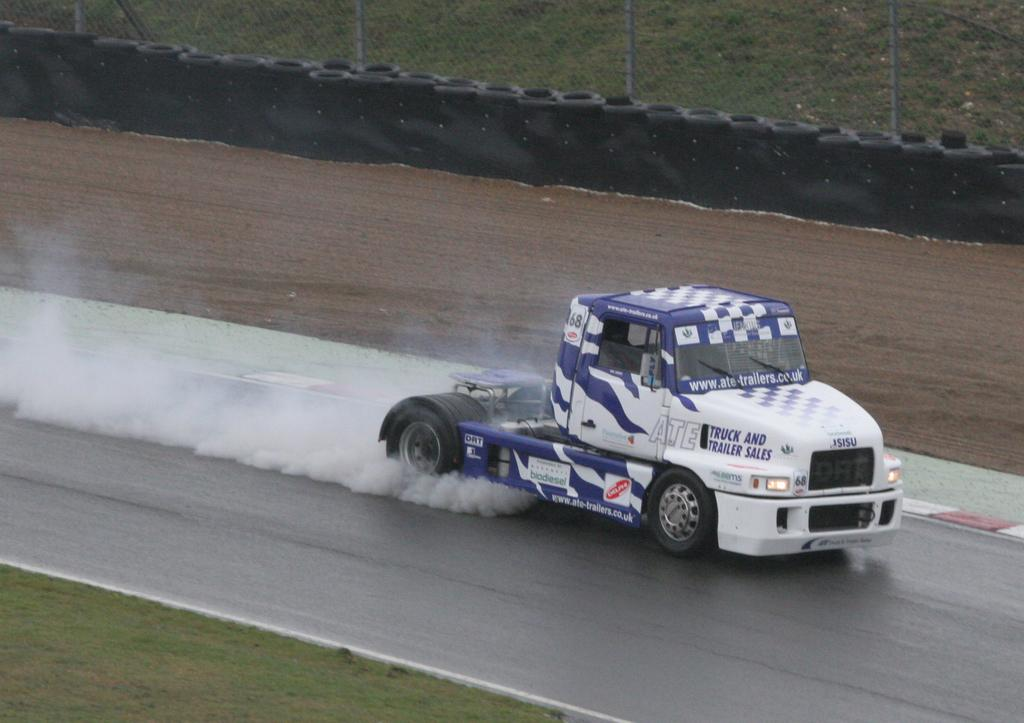What type of vehicle is on the road in the image? There is a trailer truck on the road in the image. What type of vegetation is visible at the bottom of the image? There is grass at the bottom of the image. What can be seen in the background of the image? In the background of the image, there is a fence, a wall, a road, and other objects. What type of pie is being served on the wall in the image? There is no pie present in the image; the wall is part of the background and does not have any food items on it. 